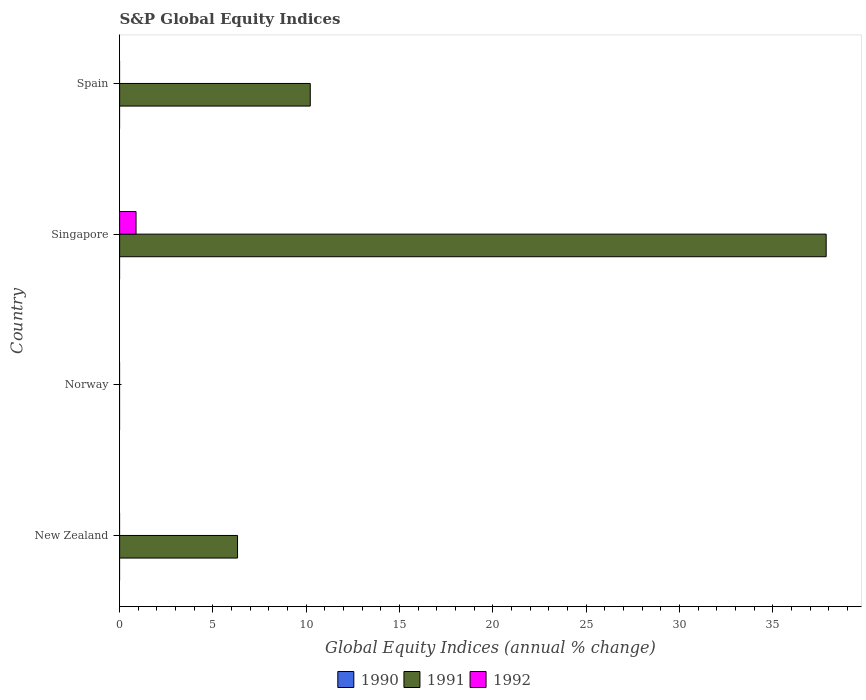How many different coloured bars are there?
Provide a succinct answer. 2. Are the number of bars on each tick of the Y-axis equal?
Give a very brief answer. No. How many bars are there on the 3rd tick from the bottom?
Make the answer very short. 2. In how many cases, is the number of bars for a given country not equal to the number of legend labels?
Keep it short and to the point. 4. What is the global equity indices in 1992 in Norway?
Keep it short and to the point. 0. Across all countries, what is the maximum global equity indices in 1992?
Give a very brief answer. 0.88. In which country was the global equity indices in 1992 maximum?
Keep it short and to the point. Singapore. What is the difference between the global equity indices in 1991 in New Zealand and that in Spain?
Your response must be concise. -3.9. What is the difference between the global equity indices in 1991 in New Zealand and the global equity indices in 1990 in Spain?
Make the answer very short. 6.32. What is the average global equity indices in 1992 per country?
Offer a terse response. 0.22. What is the ratio of the global equity indices in 1991 in New Zealand to that in Spain?
Offer a terse response. 0.62. What is the difference between the highest and the second highest global equity indices in 1991?
Your answer should be very brief. 27.64. What is the difference between the highest and the lowest global equity indices in 1992?
Provide a short and direct response. 0.88. In how many countries, is the global equity indices in 1991 greater than the average global equity indices in 1991 taken over all countries?
Your answer should be very brief. 1. Is it the case that in every country, the sum of the global equity indices in 1992 and global equity indices in 1991 is greater than the global equity indices in 1990?
Offer a very short reply. No. How many bars are there?
Make the answer very short. 4. How many countries are there in the graph?
Give a very brief answer. 4. What is the difference between two consecutive major ticks on the X-axis?
Give a very brief answer. 5. Are the values on the major ticks of X-axis written in scientific E-notation?
Provide a succinct answer. No. How many legend labels are there?
Ensure brevity in your answer.  3. How are the legend labels stacked?
Your answer should be compact. Horizontal. What is the title of the graph?
Provide a succinct answer. S&P Global Equity Indices. Does "1978" appear as one of the legend labels in the graph?
Ensure brevity in your answer.  No. What is the label or title of the X-axis?
Make the answer very short. Global Equity Indices (annual % change). What is the Global Equity Indices (annual % change) in 1990 in New Zealand?
Offer a terse response. 0. What is the Global Equity Indices (annual % change) of 1991 in New Zealand?
Your answer should be very brief. 6.32. What is the Global Equity Indices (annual % change) of 1992 in Norway?
Your response must be concise. 0. What is the Global Equity Indices (annual % change) in 1991 in Singapore?
Provide a succinct answer. 37.85. What is the Global Equity Indices (annual % change) in 1992 in Singapore?
Provide a succinct answer. 0.88. What is the Global Equity Indices (annual % change) in 1991 in Spain?
Your answer should be very brief. 10.21. Across all countries, what is the maximum Global Equity Indices (annual % change) in 1991?
Ensure brevity in your answer.  37.85. Across all countries, what is the maximum Global Equity Indices (annual % change) of 1992?
Make the answer very short. 0.88. Across all countries, what is the minimum Global Equity Indices (annual % change) of 1991?
Offer a terse response. 0. Across all countries, what is the minimum Global Equity Indices (annual % change) in 1992?
Your answer should be very brief. 0. What is the total Global Equity Indices (annual % change) in 1990 in the graph?
Provide a short and direct response. 0. What is the total Global Equity Indices (annual % change) in 1991 in the graph?
Offer a terse response. 54.38. What is the total Global Equity Indices (annual % change) in 1992 in the graph?
Your answer should be very brief. 0.88. What is the difference between the Global Equity Indices (annual % change) in 1991 in New Zealand and that in Singapore?
Give a very brief answer. -31.53. What is the difference between the Global Equity Indices (annual % change) of 1991 in New Zealand and that in Spain?
Make the answer very short. -3.9. What is the difference between the Global Equity Indices (annual % change) in 1991 in Singapore and that in Spain?
Provide a succinct answer. 27.64. What is the difference between the Global Equity Indices (annual % change) of 1991 in New Zealand and the Global Equity Indices (annual % change) of 1992 in Singapore?
Your response must be concise. 5.44. What is the average Global Equity Indices (annual % change) in 1990 per country?
Provide a succinct answer. 0. What is the average Global Equity Indices (annual % change) of 1991 per country?
Provide a succinct answer. 13.6. What is the average Global Equity Indices (annual % change) of 1992 per country?
Offer a very short reply. 0.22. What is the difference between the Global Equity Indices (annual % change) in 1991 and Global Equity Indices (annual % change) in 1992 in Singapore?
Give a very brief answer. 36.97. What is the ratio of the Global Equity Indices (annual % change) in 1991 in New Zealand to that in Singapore?
Ensure brevity in your answer.  0.17. What is the ratio of the Global Equity Indices (annual % change) of 1991 in New Zealand to that in Spain?
Ensure brevity in your answer.  0.62. What is the ratio of the Global Equity Indices (annual % change) in 1991 in Singapore to that in Spain?
Your answer should be very brief. 3.71. What is the difference between the highest and the second highest Global Equity Indices (annual % change) in 1991?
Your answer should be compact. 27.64. What is the difference between the highest and the lowest Global Equity Indices (annual % change) of 1991?
Offer a very short reply. 37.85. What is the difference between the highest and the lowest Global Equity Indices (annual % change) of 1992?
Your answer should be compact. 0.88. 